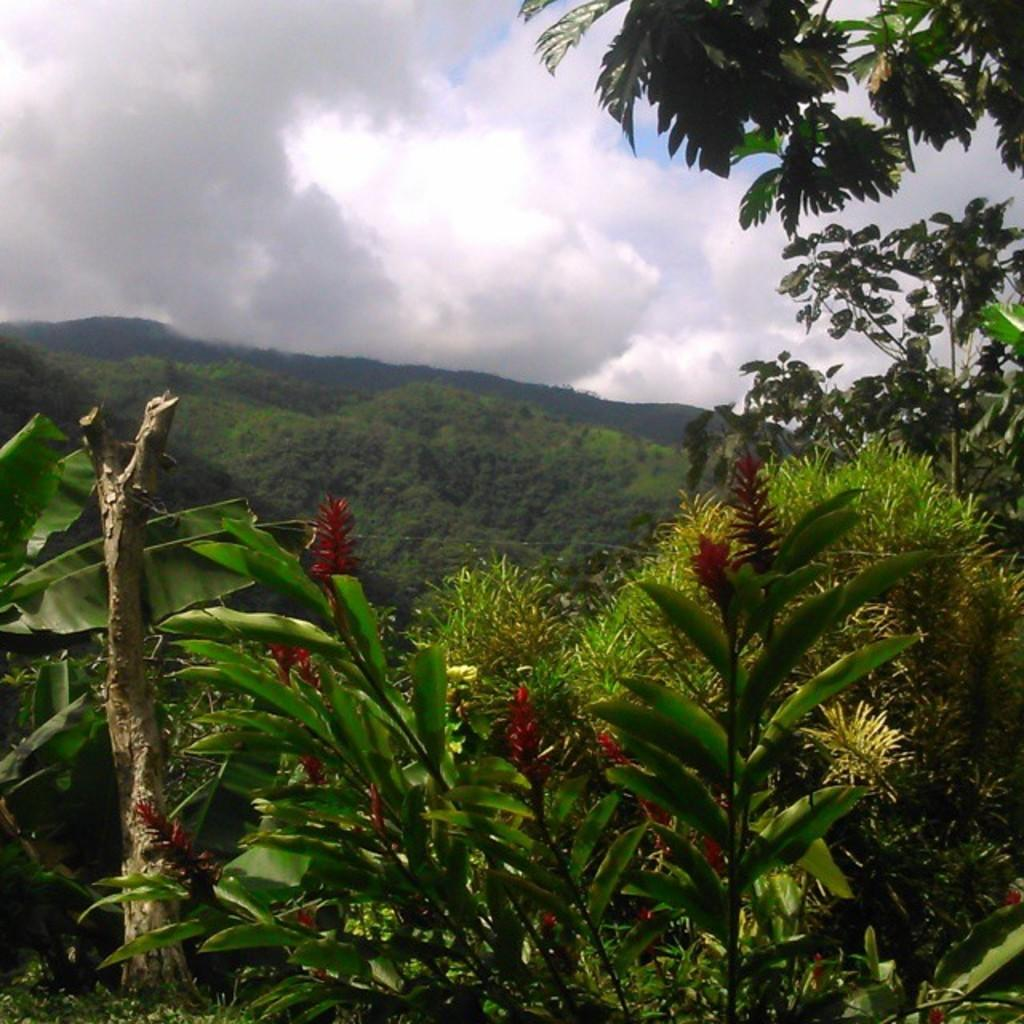What type of vegetation can be seen in the image? There are many trees, plants, and grass visible in the image. What specific part of the trees can be seen in the image? Leaves are visible in the image. What is visible in the background of the image? There are mountains in the background of the image. What is visible at the top of the image? The sky is visible at the top of the image. What can be seen in the sky? Clouds are present in the sky. Where are the father and mother located in the image? There is no father or mother present in the image. What type of base is supporting the trees in the image? The trees are not shown to be supported by any base in the image. 